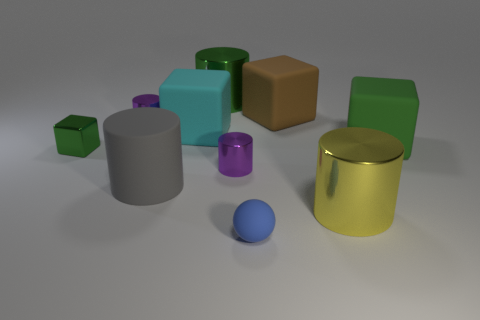There is a large cylinder behind the gray cylinder; what number of gray cylinders are on the left side of it?
Your answer should be compact. 1. What is the size of the object that is both behind the blue object and in front of the gray matte cylinder?
Make the answer very short. Large. There is a green cube that is right of the big yellow metallic object; what is it made of?
Your answer should be compact. Rubber. Are there any cyan metallic things that have the same shape as the gray thing?
Make the answer very short. No. How many brown rubber things are the same shape as the tiny green metallic object?
Keep it short and to the point. 1. There is a green metallic thing that is behind the cyan rubber cube; is it the same size as the matte cube on the left side of the tiny blue object?
Ensure brevity in your answer.  Yes. There is a small purple metallic thing that is on the left side of the purple metallic thing in front of the big green rubber block; what is its shape?
Your answer should be compact. Cylinder. Are there an equal number of brown things in front of the big gray matte thing and small green blocks?
Keep it short and to the point. No. There is a tiny purple cylinder that is in front of the small cylinder that is behind the small metal cylinder that is in front of the tiny green shiny cube; what is it made of?
Your answer should be compact. Metal. Are there any blue cylinders that have the same size as the cyan rubber object?
Your response must be concise. No. 